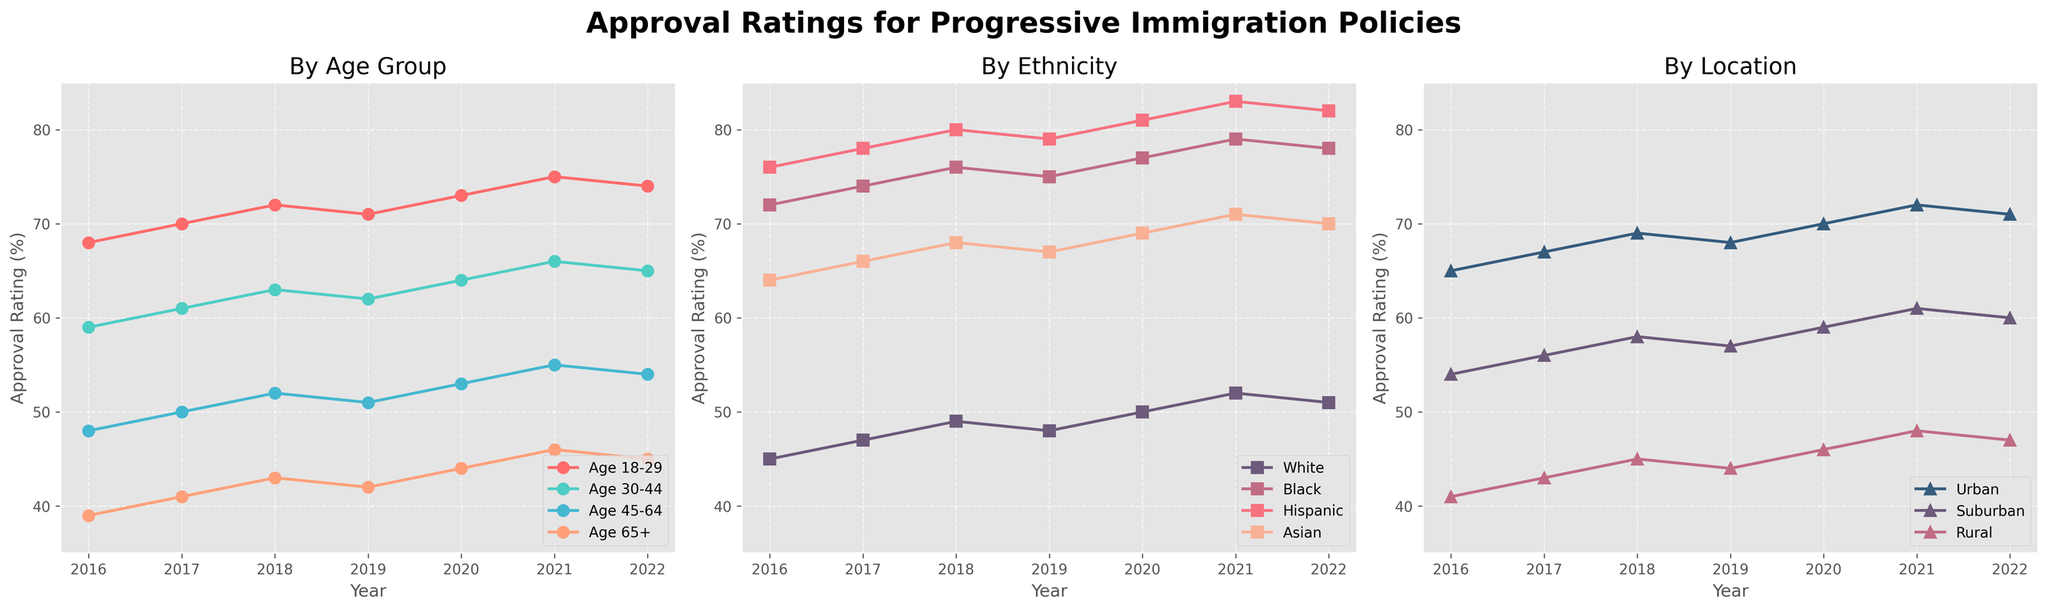What is the title of the plot? The title of the plot is displayed at the top and indicates the focus of the figure. The title reads "Approval Ratings for Progressive Immigration Policies".
Answer: Approval Ratings for Progressive Immigration Policies Which age group has the highest approval rating in 2022? In the subplot "By Age Group", the lines representing different age groups are plotted. On the 2022 marker, the line for "Age 18-29" is at the highest position.
Answer: Age 18-29 By how much did the approval rating of the "Urban" group change from 2016 to 2022? In the subplot "By Location", the "Urban" line is tracked from 2016 to 2022. The approval rating for "Urban" in 2016 is 65% and in 2022 it is 71%. The difference is \(71 - 65 = 6\).
Answer: 6% What is the average approval rating of the "Hispanic" group over the given years? To find the average, sum the approval ratings of the "Hispanic" group from 2016 to 2022, then divide by the number of years. \((76+78+80+79+81+83+82)/7 = 559/7 = 79.857\)
Answer: 79.86% Which ethnic group showed the greatest increase in approval rating between 2016 and 2022? By examining the 2016 and 2022 data points in the "By Ethnicity" subplot, calculate the increase for each group:
White: \(51-45=6\),
Black: \(78-72=6\),
Hispanic: \(82-76=6\),
Asian: \(70-64=6\).
All groups have the same increase.
Answer: All groups Which location group consistently had the lowest approval ratings throughout the years? In the subplot "By Location", the lines for "Urban", "Suburban", and "Rural" are compared across all years. The "Rural" line is consistently the lowest throughout the years.
Answer: Rural What is the difference in approval ratings between the "Black" and "White" groups in 2021? In the subplot "By Ethnicity", look at the 2021 data points. The "Black" group's rating in 2021 is 79% and the "White" group's rating is 52%. The difference is \(79 - 52 = 27\).
Answer: 27% Which age group saw a decline in approval rating from 2021 to 2022? In the subplot "By Age Group", examine the lines for any decreases from 2021 to 2022. The "Age 18-29" group has a slightly lower point in 2022 compared to 2021.
Answer: Age 18-29 How did the approval rating of the "Asian" group change over the years? In the subplot "By Ethnicity", the line for the "Asian" group shows a steady increase from 64% in 2016 to 71% in 2022.
Answer: Increased by 7% 